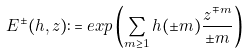Convert formula to latex. <formula><loc_0><loc_0><loc_500><loc_500>E ^ { \pm } ( h , z ) \colon = e x p \left ( \sum _ { m \geq 1 } h ( \pm m ) \frac { z ^ { \mp m } } { \pm m } \right )</formula> 